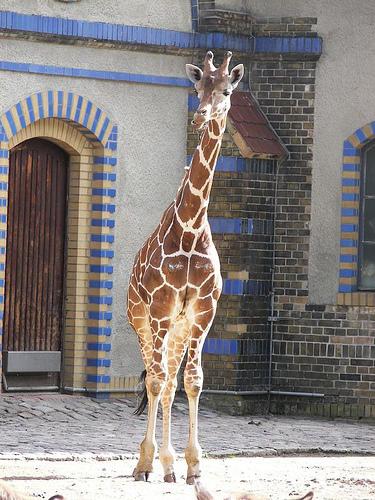How many spots are on the giraffe?
Short answer required. Many. What color are the spots on the giraffe?
Concise answer only. Brown. What animal is shown?
Give a very brief answer. Giraffe. What color is the wall?
Short answer required. Gray and blue. What is the wall made of?
Quick response, please. Brick. 